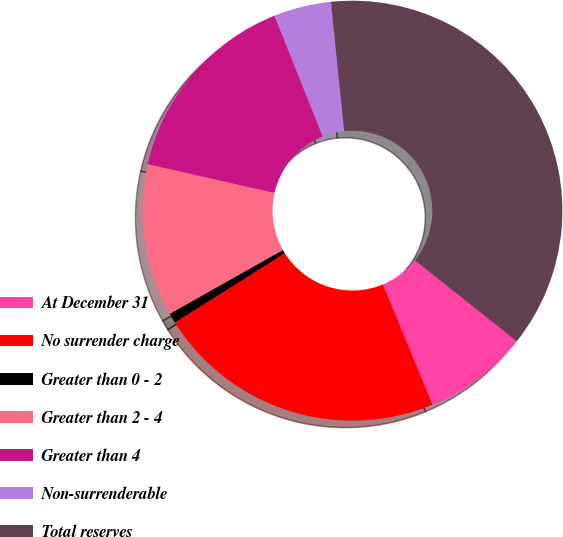<chart> <loc_0><loc_0><loc_500><loc_500><pie_chart><fcel>At December 31<fcel>No surrender charge<fcel>Greater than 0 - 2<fcel>Greater than 2 - 4<fcel>Greater than 4<fcel>Non-surrenderable<fcel>Total reserves<nl><fcel>8.08%<fcel>22.28%<fcel>0.77%<fcel>11.74%<fcel>15.39%<fcel>4.42%<fcel>37.32%<nl></chart> 